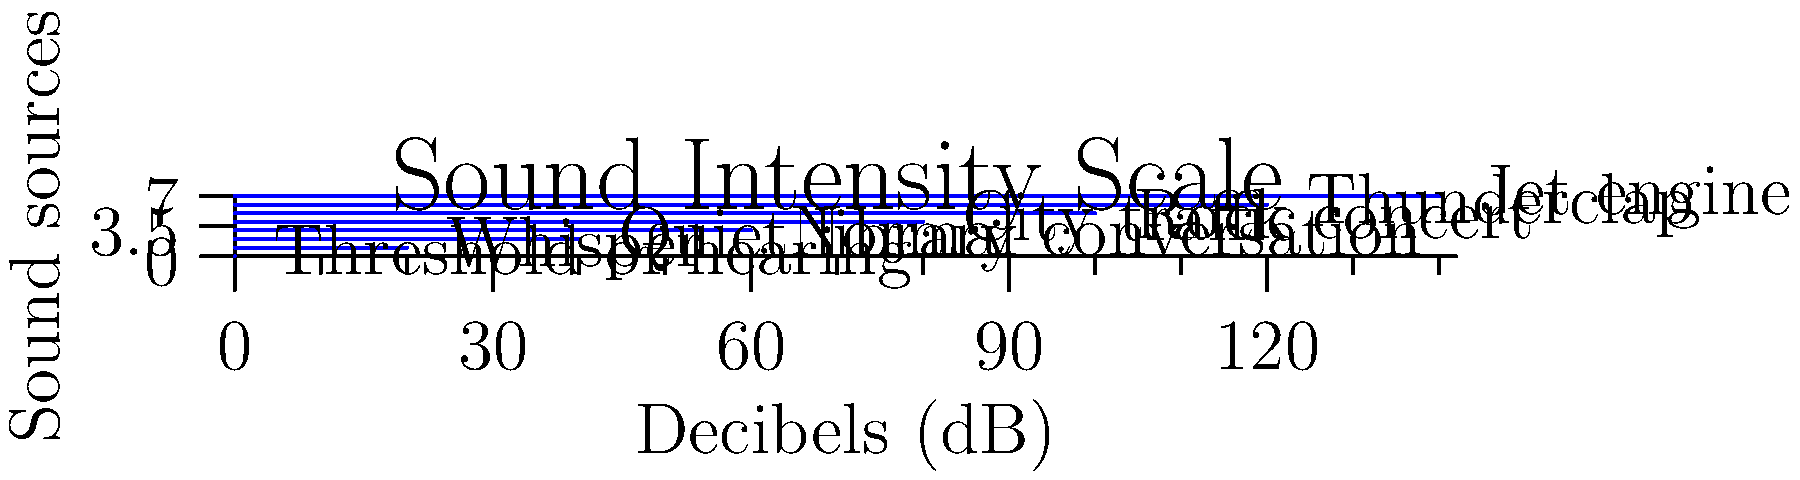As a fan of Kristiana Levy's music, you're curious about sound intensity levels at her concerts. According to the diagram, at approximately how many decibels would Kristiana's performance likely be, assuming it's similar in volume to a typical rock concert? To answer this question, we need to follow these steps:

1. Examine the diagram, which shows various sound sources and their corresponding decibel levels.

2. Locate the entry for "Rock concert" on the y-axis.

3. Follow the blue line from "Rock concert" to where it ends on the x-axis.

4. Read the corresponding decibel value on the x-axis.

From the diagram, we can see that the blue line for "Rock concert" extends to approximately 100 decibels on the x-axis.

Therefore, assuming Kristiana Levy's concert is similar in volume to a typical rock concert, it would likely be around 100 decibels.

It's worth noting that prolonged exposure to sound levels above 85 decibels can potentially cause hearing damage, so it's important to use hearing protection at concerts.
Answer: 100 dB 